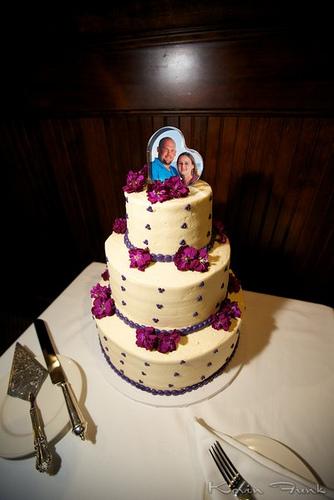What event has taken place?
Answer briefly. Wedding. What color are the flowers?
Write a very short answer. Purple. What type of party would this cake be for?
Short answer required. Wedding. How many utensils are in the table?
Short answer required. 3. What colors are the cake?
Write a very short answer. White and purple. What is the diamond shaped utensil for?
Short answer required. Serving. What type of cake is this?
Quick response, please. Wedding. How many tiers on the cake?
Quick response, please. 3. 